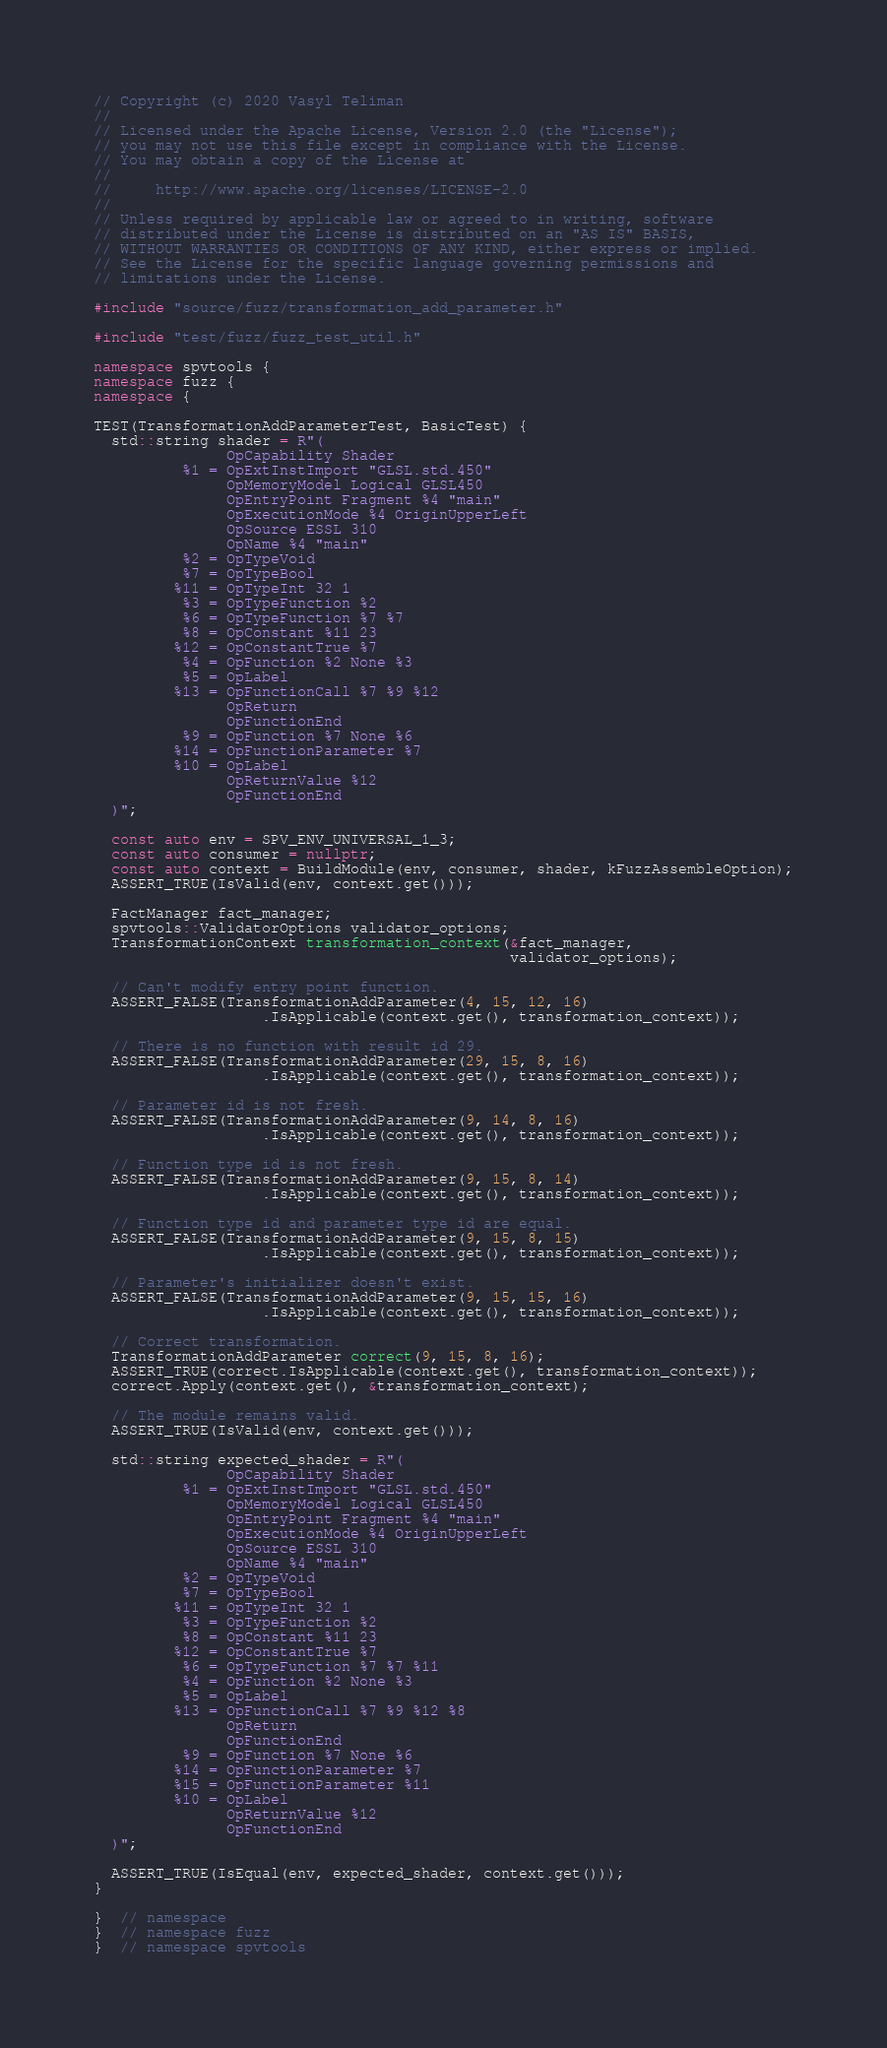<code> <loc_0><loc_0><loc_500><loc_500><_C++_>// Copyright (c) 2020 Vasyl Teliman
//
// Licensed under the Apache License, Version 2.0 (the "License");
// you may not use this file except in compliance with the License.
// You may obtain a copy of the License at
//
//     http://www.apache.org/licenses/LICENSE-2.0
//
// Unless required by applicable law or agreed to in writing, software
// distributed under the License is distributed on an "AS IS" BASIS,
// WITHOUT WARRANTIES OR CONDITIONS OF ANY KIND, either express or implied.
// See the License for the specific language governing permissions and
// limitations under the License.

#include "source/fuzz/transformation_add_parameter.h"

#include "test/fuzz/fuzz_test_util.h"

namespace spvtools {
namespace fuzz {
namespace {

TEST(TransformationAddParameterTest, BasicTest) {
  std::string shader = R"(
               OpCapability Shader
          %1 = OpExtInstImport "GLSL.std.450"
               OpMemoryModel Logical GLSL450
               OpEntryPoint Fragment %4 "main"
               OpExecutionMode %4 OriginUpperLeft
               OpSource ESSL 310
               OpName %4 "main"
          %2 = OpTypeVoid
          %7 = OpTypeBool
         %11 = OpTypeInt 32 1
          %3 = OpTypeFunction %2
          %6 = OpTypeFunction %7 %7
          %8 = OpConstant %11 23
         %12 = OpConstantTrue %7
          %4 = OpFunction %2 None %3
          %5 = OpLabel
         %13 = OpFunctionCall %7 %9 %12
               OpReturn
               OpFunctionEnd
          %9 = OpFunction %7 None %6
         %14 = OpFunctionParameter %7
         %10 = OpLabel
               OpReturnValue %12
               OpFunctionEnd
  )";

  const auto env = SPV_ENV_UNIVERSAL_1_3;
  const auto consumer = nullptr;
  const auto context = BuildModule(env, consumer, shader, kFuzzAssembleOption);
  ASSERT_TRUE(IsValid(env, context.get()));

  FactManager fact_manager;
  spvtools::ValidatorOptions validator_options;
  TransformationContext transformation_context(&fact_manager,
                                               validator_options);

  // Can't modify entry point function.
  ASSERT_FALSE(TransformationAddParameter(4, 15, 12, 16)
                   .IsApplicable(context.get(), transformation_context));

  // There is no function with result id 29.
  ASSERT_FALSE(TransformationAddParameter(29, 15, 8, 16)
                   .IsApplicable(context.get(), transformation_context));

  // Parameter id is not fresh.
  ASSERT_FALSE(TransformationAddParameter(9, 14, 8, 16)
                   .IsApplicable(context.get(), transformation_context));

  // Function type id is not fresh.
  ASSERT_FALSE(TransformationAddParameter(9, 15, 8, 14)
                   .IsApplicable(context.get(), transformation_context));

  // Function type id and parameter type id are equal.
  ASSERT_FALSE(TransformationAddParameter(9, 15, 8, 15)
                   .IsApplicable(context.get(), transformation_context));

  // Parameter's initializer doesn't exist.
  ASSERT_FALSE(TransformationAddParameter(9, 15, 15, 16)
                   .IsApplicable(context.get(), transformation_context));

  // Correct transformation.
  TransformationAddParameter correct(9, 15, 8, 16);
  ASSERT_TRUE(correct.IsApplicable(context.get(), transformation_context));
  correct.Apply(context.get(), &transformation_context);

  // The module remains valid.
  ASSERT_TRUE(IsValid(env, context.get()));

  std::string expected_shader = R"(
               OpCapability Shader
          %1 = OpExtInstImport "GLSL.std.450"
               OpMemoryModel Logical GLSL450
               OpEntryPoint Fragment %4 "main"
               OpExecutionMode %4 OriginUpperLeft
               OpSource ESSL 310
               OpName %4 "main"
          %2 = OpTypeVoid
          %7 = OpTypeBool
         %11 = OpTypeInt 32 1
          %3 = OpTypeFunction %2
          %8 = OpConstant %11 23
         %12 = OpConstantTrue %7
          %6 = OpTypeFunction %7 %7 %11
          %4 = OpFunction %2 None %3
          %5 = OpLabel
         %13 = OpFunctionCall %7 %9 %12 %8
               OpReturn
               OpFunctionEnd
          %9 = OpFunction %7 None %6
         %14 = OpFunctionParameter %7
         %15 = OpFunctionParameter %11
         %10 = OpLabel
               OpReturnValue %12
               OpFunctionEnd
  )";

  ASSERT_TRUE(IsEqual(env, expected_shader, context.get()));
}

}  // namespace
}  // namespace fuzz
}  // namespace spvtools
</code> 